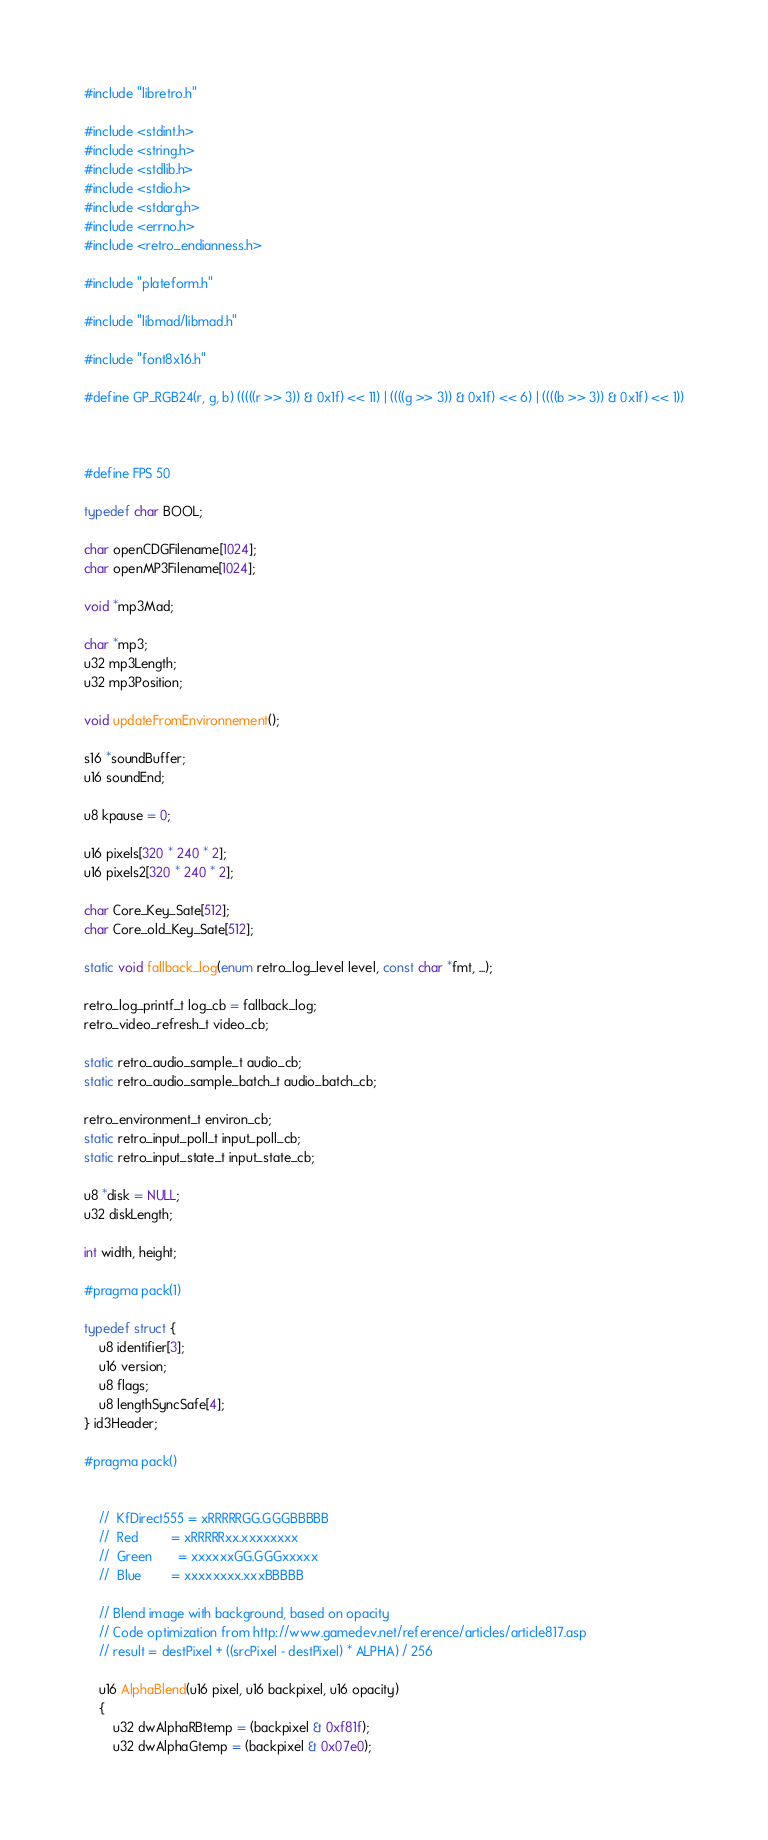Convert code to text. <code><loc_0><loc_0><loc_500><loc_500><_C_>#include "libretro.h"

#include <stdint.h>
#include <string.h>
#include <stdlib.h>
#include <stdio.h>
#include <stdarg.h>
#include <errno.h>
#include <retro_endianness.h>

#include "plateform.h"

#include "libmad/libmad.h"

#include "font8x16.h"

#define GP_RGB24(r, g, b) (((((r >> 3)) & 0x1f) << 11) | ((((g >> 3)) & 0x1f) << 6) | ((((b >> 3)) & 0x1f) << 1))



#define FPS 50

typedef char BOOL;

char openCDGFilename[1024];
char openMP3Filename[1024];

void *mp3Mad;

char *mp3;
u32 mp3Length;
u32 mp3Position;

void updateFromEnvironnement();

s16 *soundBuffer;
u16 soundEnd;

u8 kpause = 0;

u16 pixels[320 * 240 * 2];
u16 pixels2[320 * 240 * 2];

char Core_Key_Sate[512];
char Core_old_Key_Sate[512];

static void fallback_log(enum retro_log_level level, const char *fmt, ...);

retro_log_printf_t log_cb = fallback_log;
retro_video_refresh_t video_cb;

static retro_audio_sample_t audio_cb;
static retro_audio_sample_batch_t audio_batch_cb;

retro_environment_t environ_cb;
static retro_input_poll_t input_poll_cb;
static retro_input_state_t input_state_cb;

u8 *disk = NULL;
u32 diskLength;

int width, height;

#pragma pack(1)

typedef struct {
    u8 identifier[3];
    u16 version;
    u8 flags;
    u8 lengthSyncSafe[4];
} id3Header;

#pragma pack()


    //  KfDirect555 = xRRRRRGG.GGGBBBBB
    //  Red         = xRRRRRxx.xxxxxxxx
    //  Green       = xxxxxxGG.GGGxxxxx
    //  Blue        = xxxxxxxx.xxxBBBBB

    // Blend image with background, based on opacity
    // Code optimization from http://www.gamedev.net/reference/articles/article817.asp
    // result = destPixel + ((srcPixel - destPixel) * ALPHA) / 256

    u16 AlphaBlend(u16 pixel, u16 backpixel, u16 opacity)
    {
        u32 dwAlphaRBtemp = (backpixel & 0xf81f);
        u32 dwAlphaGtemp = (backpixel & 0x07e0);</code> 